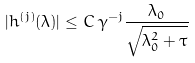<formula> <loc_0><loc_0><loc_500><loc_500>| h ^ { ( j ) } ( \lambda ) | \leq C \, \gamma ^ { - j } \frac { \lambda _ { 0 } } { \sqrt { \lambda _ { 0 } ^ { 2 } + \tau } }</formula> 